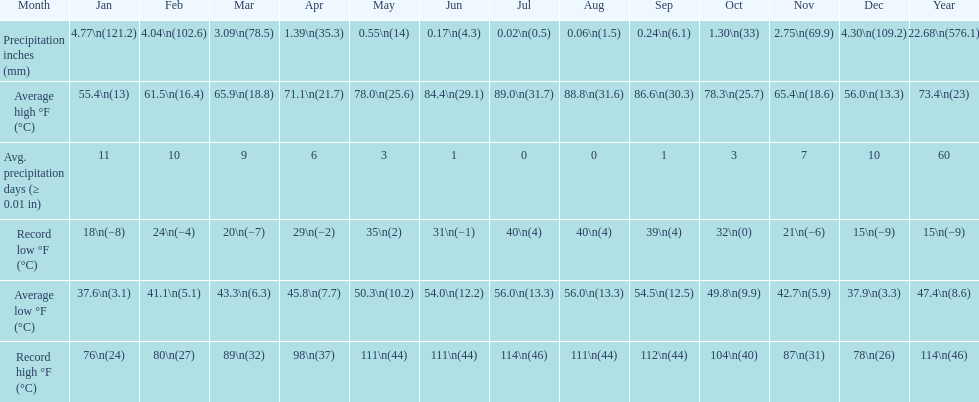0 degrees? July. 